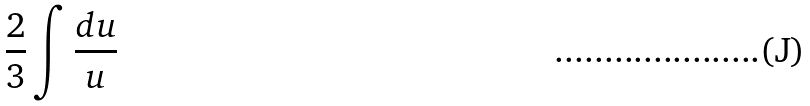Convert formula to latex. <formula><loc_0><loc_0><loc_500><loc_500>\frac { 2 } { 3 } \int \frac { d u } { u }</formula> 